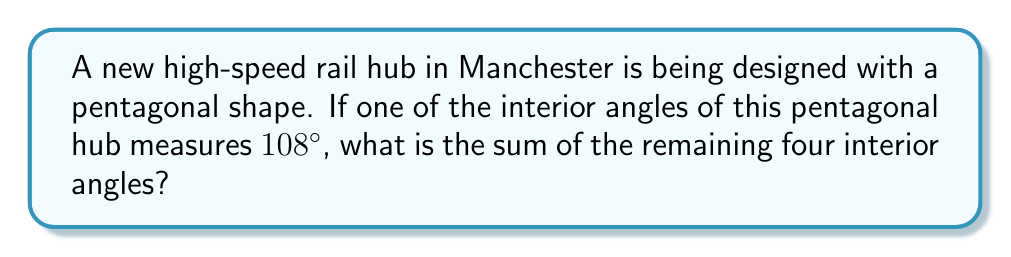Can you solve this math problem? Let's approach this step-by-step:

1) First, recall that the sum of interior angles of a pentagon is given by the formula:
   $$(n-2) \times 180°$$
   where $n$ is the number of sides.

2) For a pentagon, $n = 5$, so the sum of interior angles is:
   $$(5-2) \times 180° = 3 \times 180° = 540°$$

3) We're told that one of the angles is 108°. Let's call the sum of the remaining four angles $x$.

4) We can set up an equation:
   $$x + 108° = 540°$$

5) Solving for $x$:
   $$x = 540° - 108° = 432°$$

Therefore, the sum of the remaining four interior angles is 432°.
Answer: 432° 